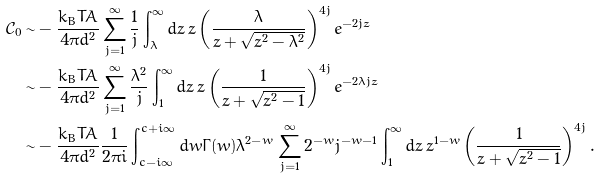<formula> <loc_0><loc_0><loc_500><loc_500>\mathcal { C } _ { 0 } \sim & - \frac { k _ { B } T A } { 4 \pi d ^ { 2 } } \sum _ { j = 1 } ^ { \infty } \frac { 1 } { j } \int _ { \lambda } ^ { \infty } d z \, z \left ( \frac { \lambda } { z + \sqrt { z ^ { 2 } - \lambda ^ { 2 } } } \right ) ^ { 4 j } e ^ { - 2 j z } \\ \sim & - \frac { k _ { B } T A } { 4 \pi d ^ { 2 } } \sum _ { j = 1 } ^ { \infty } \frac { \lambda ^ { 2 } } { j } \int _ { 1 } ^ { \infty } d z \, z \left ( \frac { 1 } { z + \sqrt { z ^ { 2 } - 1 } } \right ) ^ { 4 j } e ^ { - 2 \lambda j z } \\ \sim & - \frac { k _ { B } T A } { 4 \pi d ^ { 2 } } \frac { 1 } { 2 \pi i } \int _ { c - i \infty } ^ { c + i \infty } d w \Gamma ( w ) \lambda ^ { 2 - w } \sum _ { j = 1 } ^ { \infty } 2 ^ { - w } j ^ { - w - 1 } \int _ { 1 } ^ { \infty } d z \, z ^ { 1 - w } \left ( \frac { 1 } { z + \sqrt { z ^ { 2 } - 1 } } \right ) ^ { 4 j } .</formula> 